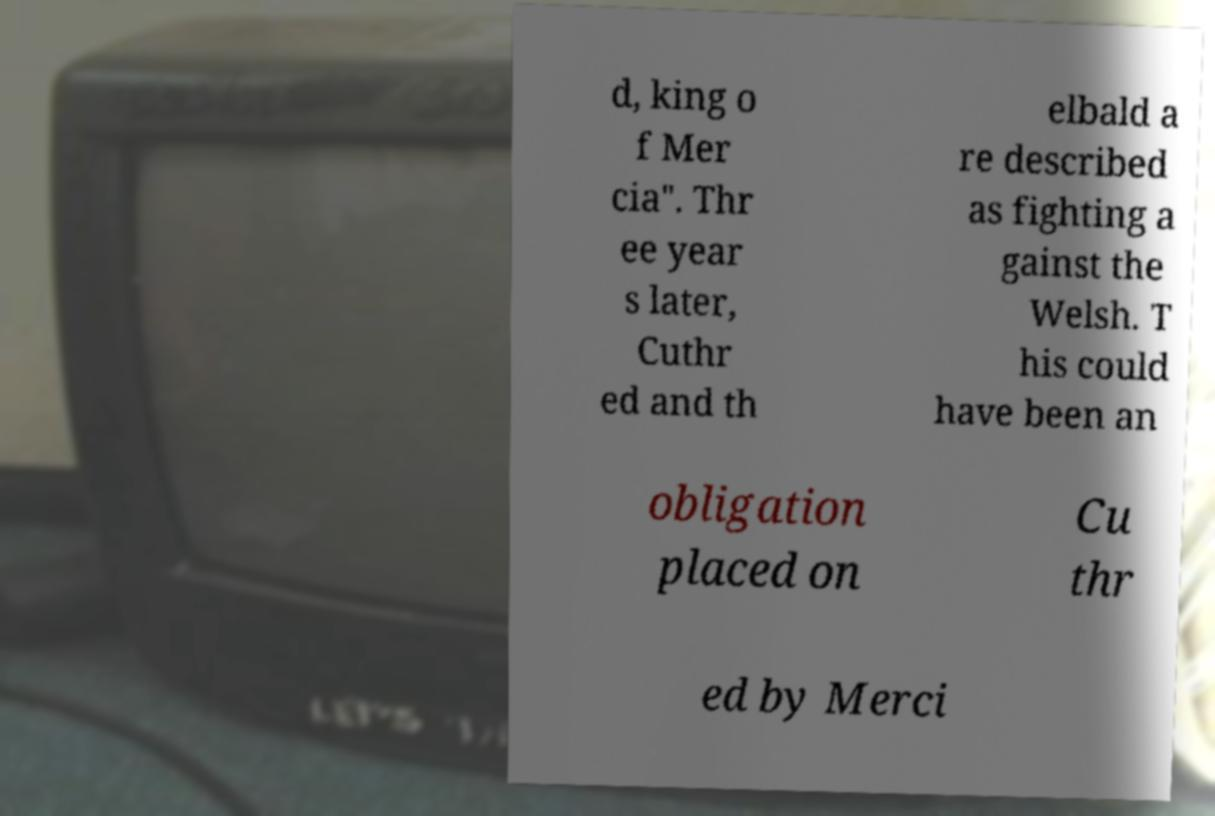Could you assist in decoding the text presented in this image and type it out clearly? d, king o f Mer cia". Thr ee year s later, Cuthr ed and th elbald a re described as fighting a gainst the Welsh. T his could have been an obligation placed on Cu thr ed by Merci 